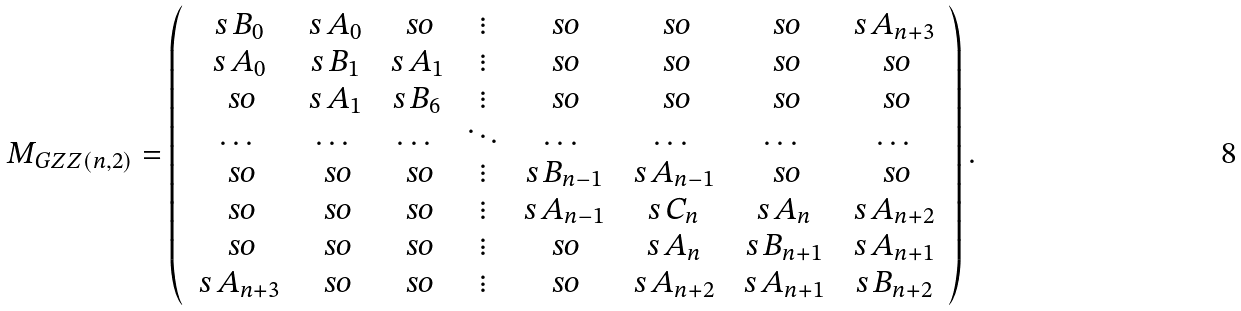Convert formula to latex. <formula><loc_0><loc_0><loc_500><loc_500>M _ { G Z Z ( n , 2 ) } = \left ( \begin{array} { c c c c c c c c } \ s { \, B _ { 0 } \, } & \ s { \, A _ { 0 } \, } & \ s o & \vdots & \ s o & \ s o & \ s o & \ s { \, A _ { n + 3 } \, } \\ \ s { \, A _ { 0 } \, } & \ s { \, B _ { 1 } \, } & \ s { \, A _ { 1 } \, } & \vdots & \ s o & \ s o & \ s o & \ s o \\ \ s o & \ s { \, A _ { 1 } \, } & \ s { \, B _ { 6 } \, } & \vdots & \ s o & \ s o & \ s o & \ s o \\ \dots & \dots & \dots & \ddots & \dots & \dots & \dots & \dots \\ \ s o & \ s o & \ s o & \vdots & \ s { \, B _ { n - 1 } \, } & \ s { \, A _ { n - 1 } \, } & \ s o & \ s o \\ \ s o & \ s o & \ s o & \vdots & \ s { \, A _ { n - 1 } \, } & \ s { \, C _ { n } \, } & \ s { \, A _ { n } \, } & \ s { \, A _ { n + 2 } \, } \\ \ s o & \ s o & \ s o & \vdots & \ s o & \ s { \, A _ { n } \, } & \ s { \, B _ { n + 1 } \, } & \ s { \, A _ { n + 1 } \, } \\ \ s { \, A _ { n + 3 } \, } & \ s o & \ s o & \vdots & \ s o & \ s { \, A _ { n + 2 } \, } & \ s { \, A _ { n + 1 } \, } & \ s { \, B _ { n + 2 } \, } \\ \end{array} \right ) .</formula> 